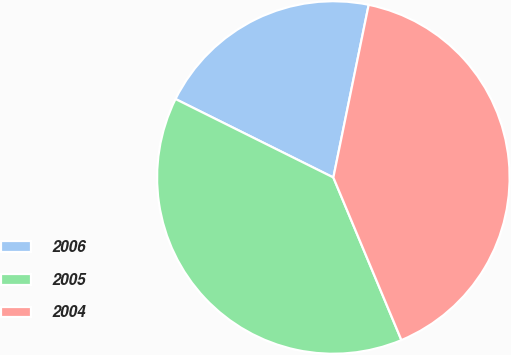Convert chart to OTSL. <chart><loc_0><loc_0><loc_500><loc_500><pie_chart><fcel>2006<fcel>2005<fcel>2004<nl><fcel>20.87%<fcel>38.65%<fcel>40.48%<nl></chart> 